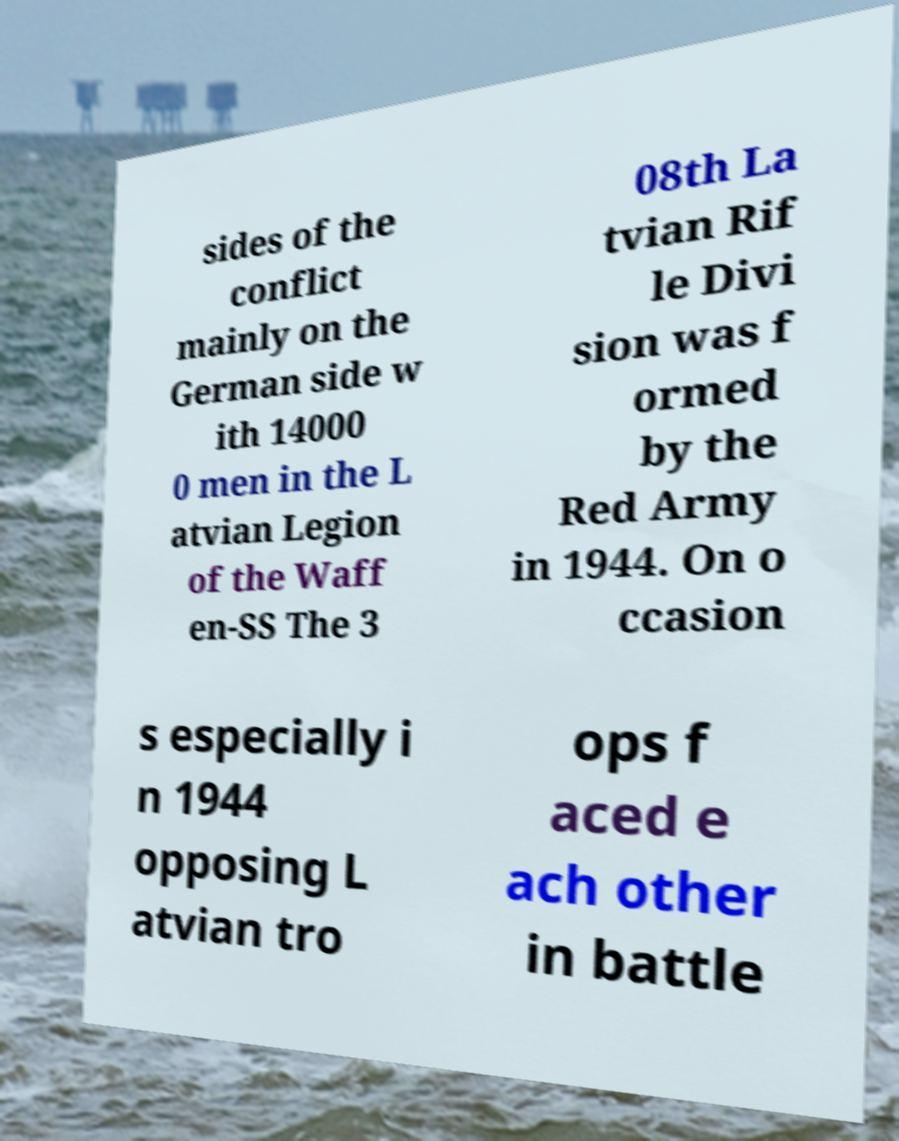Could you assist in decoding the text presented in this image and type it out clearly? sides of the conflict mainly on the German side w ith 14000 0 men in the L atvian Legion of the Waff en-SS The 3 08th La tvian Rif le Divi sion was f ormed by the Red Army in 1944. On o ccasion s especially i n 1944 opposing L atvian tro ops f aced e ach other in battle 